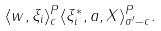<formula> <loc_0><loc_0><loc_500><loc_500>\langle w , \xi _ { i } \rangle ^ { P } _ { c } \langle \xi _ { i } ^ { * } , a , X \rangle ^ { P } _ { \sigma ^ { \prime } - c } .</formula> 